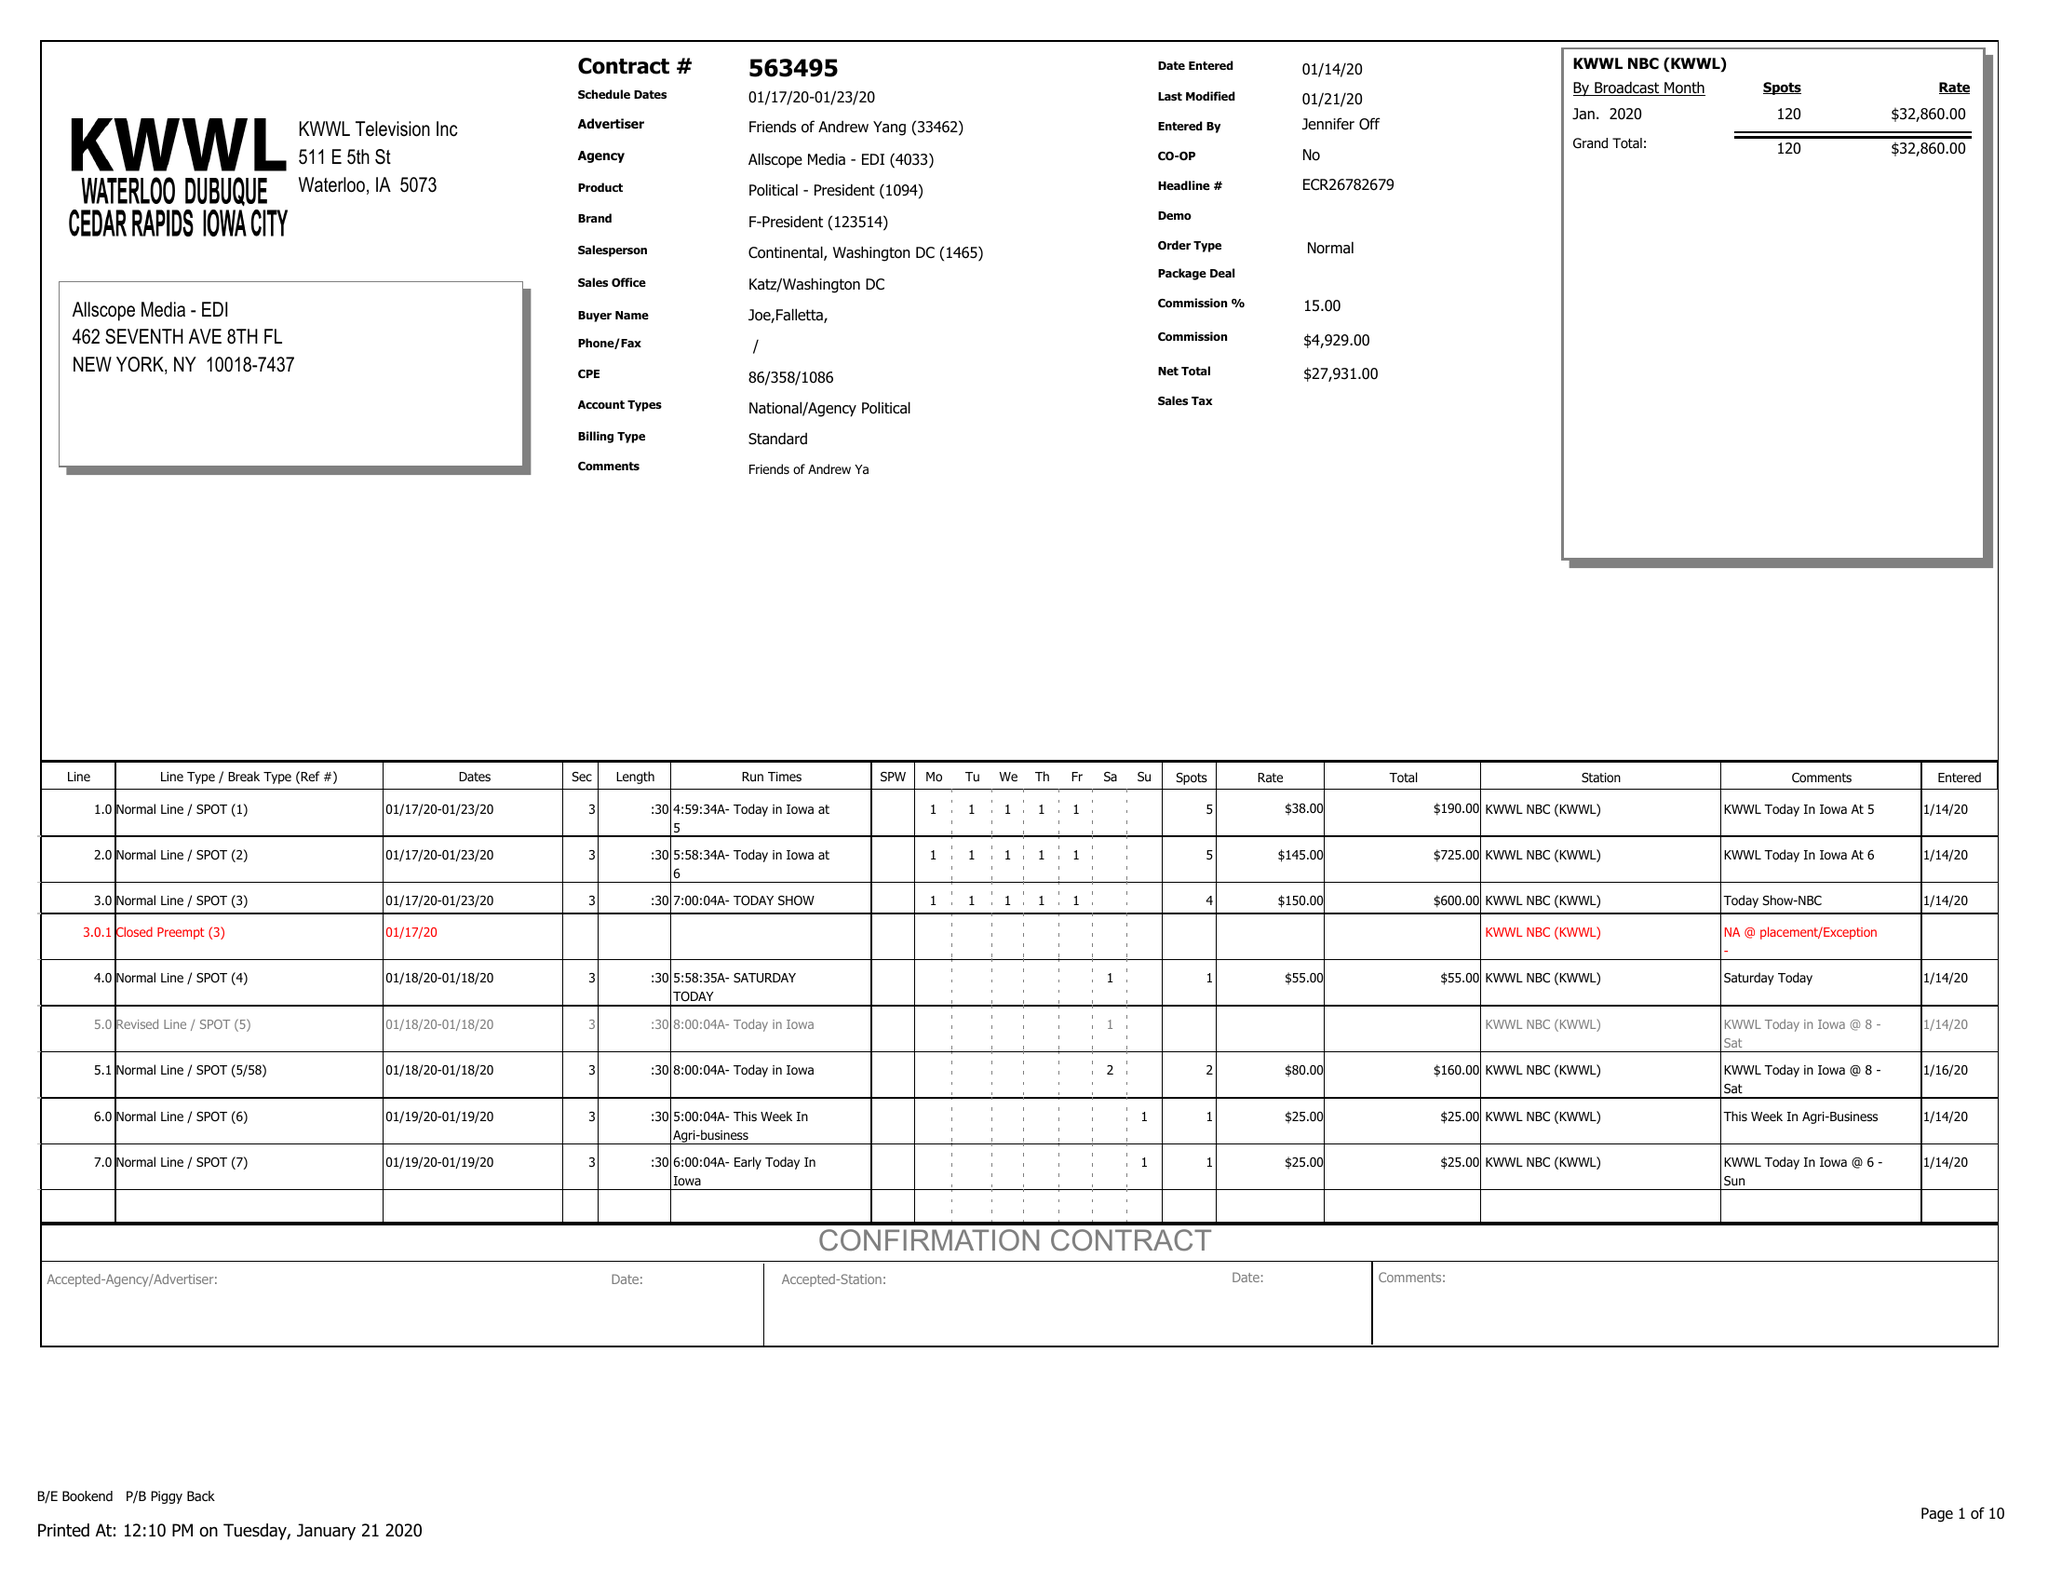What is the value for the flight_to?
Answer the question using a single word or phrase. 01/23/20 